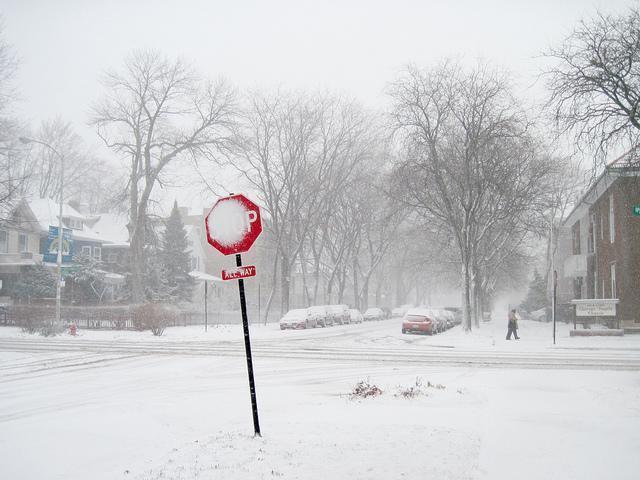How many train tracks are there?
Give a very brief answer. 0. 